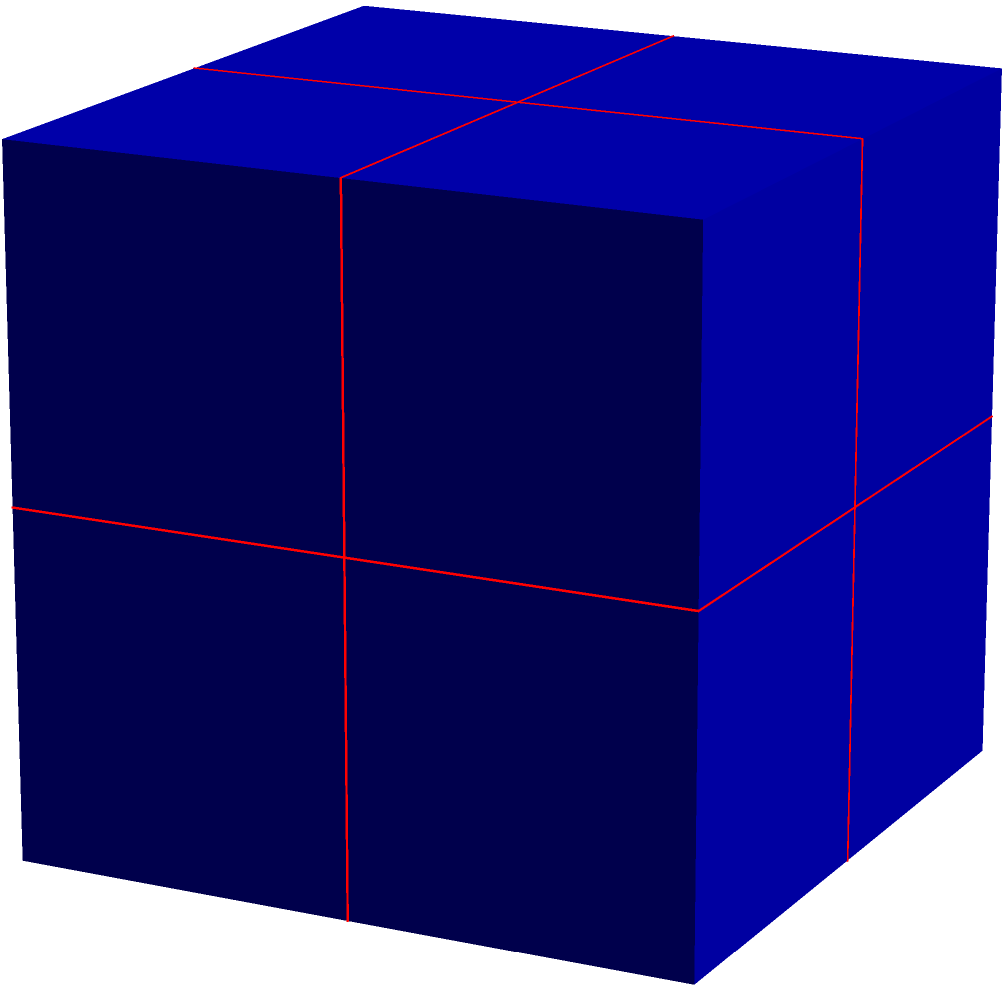Consider a cube with side length 1 and a point $P(0.5,0,0)$ on one of its edges. Under the action of the rotational symmetry group of the cube, what is the total number of distinct points in the orbit of $P$? How does this relate to the stabilizer subgroup of $P$? To solve this problem, we'll follow these steps:

1) First, let's understand what the rotational symmetry group of a cube is:
   - It consists of 24 rotations that preserve the cube's orientation.

2) Now, let's consider the point $P(0.5,0,0)$:
   - It's located at the middle of an edge of the cube.

3) Under the action of the rotational symmetry group:
   - $P$ can be mapped to the middle of any edge of the cube.
   - There are 12 edges in a cube.

4) Therefore, the orbit of $P$ consists of 12 distinct points:
   - These are the midpoints of all 12 edges of the cube.

5) The orbit-stabilizer theorem states that:
   $|G| = |Orbit(P)| \cdot |Stab(P)|$
   Where $G$ is the group, $Orbit(P)$ is the orbit of $P$, and $Stab(P)$ is the stabilizer of $P$.

6) We know that $|G| = 24$ (the order of the rotational symmetry group of a cube) and $|Orbit(P)| = 12$.

7) Using the orbit-stabilizer theorem:
   $24 = 12 \cdot |Stab(P)|$
   $|Stab(P)| = 2$

8) This means that there are 2 rotations that leave $P$ fixed:
   - The identity rotation
   - The 180° rotation around the axis passing through the midpoints of the edge containing $P$ and the opposite edge.
Answer: 12 points in orbit; stabilizer subgroup has order 2. 